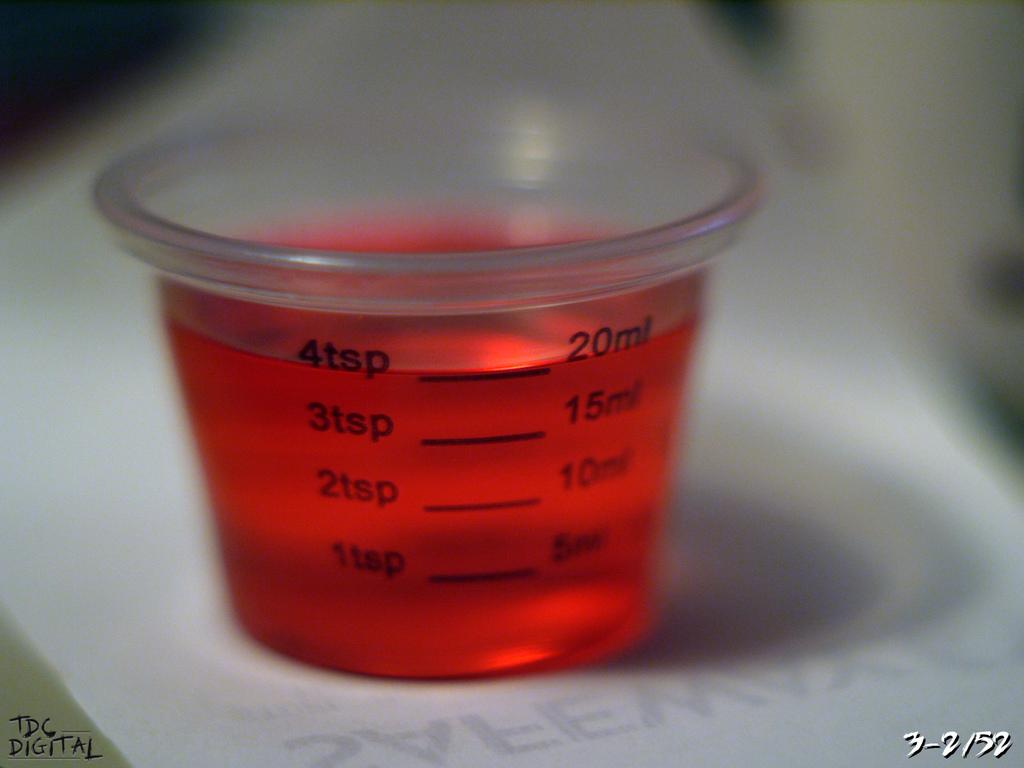How much liquid does this cup hold?
Your answer should be very brief. 20ml. What dose is on the right side?
Your answer should be very brief. 20 ml. 